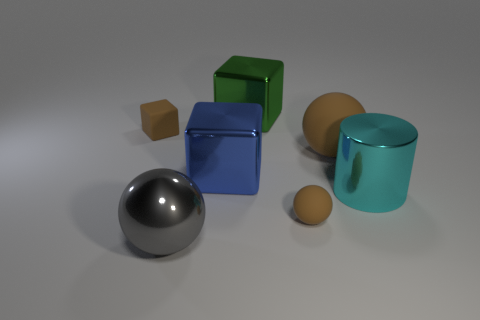What can we deduce about the lighting environment in which these objects are placed? The lighting in the image is soft and diffuse, likely an artificial source based on the even spread of light across the objects. The lack of harsh shadows or bright highlights suggests indoor lighting, probably from a single overhead light source. The mild reflections on the glossy objects like the metal sphere and the cyan object furthermore indicate the light source is not extremely bright or direct. 